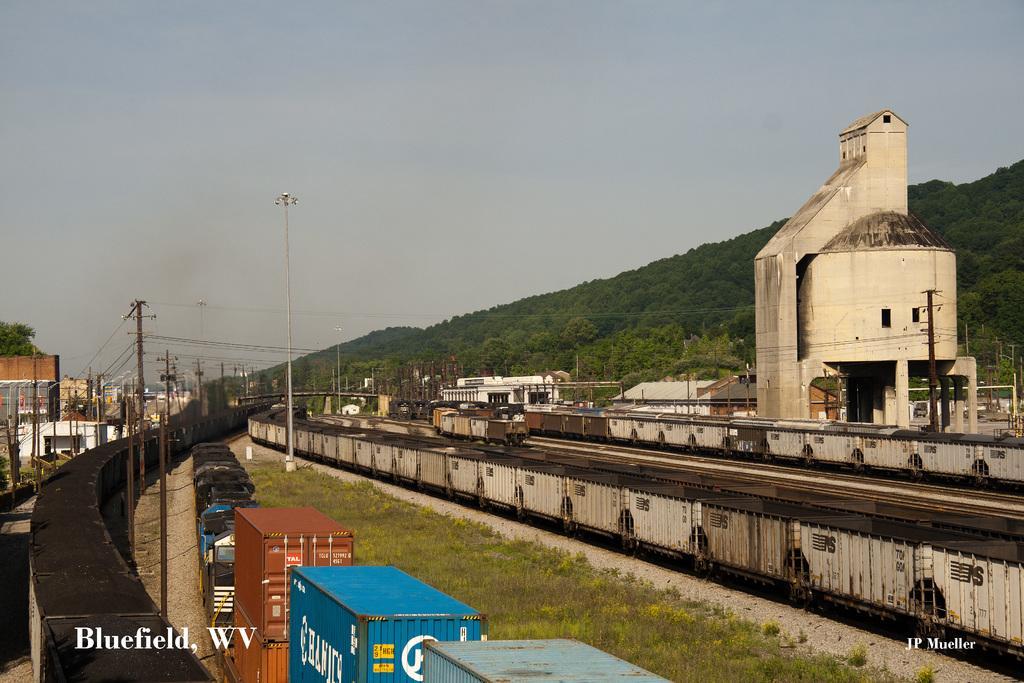Can you describe this image briefly? In this image we can see trains, containers, poles with wires and lights, there are few trees, buildings and the sky in the background. 